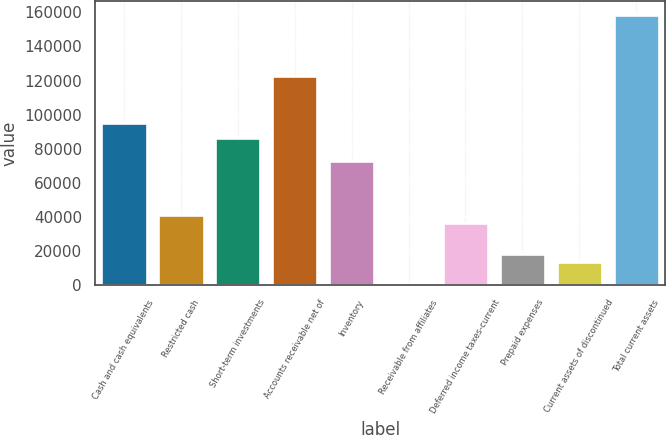<chart> <loc_0><loc_0><loc_500><loc_500><bar_chart><fcel>Cash and cash equivalents<fcel>Restricted cash<fcel>Short-term investments<fcel>Accounts receivable net of<fcel>Inventory<fcel>Receivable from affiliates<fcel>Deferred income taxes-current<fcel>Prepaid expenses<fcel>Current assets of discontinued<fcel>Total current assets<nl><fcel>95191.6<fcel>40800.4<fcel>86126.4<fcel>122387<fcel>72528.6<fcel>7<fcel>36267.8<fcel>18137.4<fcel>13604.8<fcel>158648<nl></chart> 